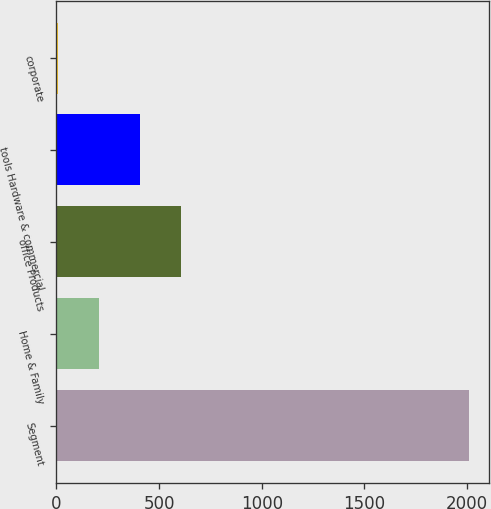Convert chart to OTSL. <chart><loc_0><loc_0><loc_500><loc_500><bar_chart><fcel>Segment<fcel>Home & Family<fcel>office Products<fcel>tools Hardware & commercial<fcel>corporate<nl><fcel>2007<fcel>205.29<fcel>605.67<fcel>405.48<fcel>5.1<nl></chart> 